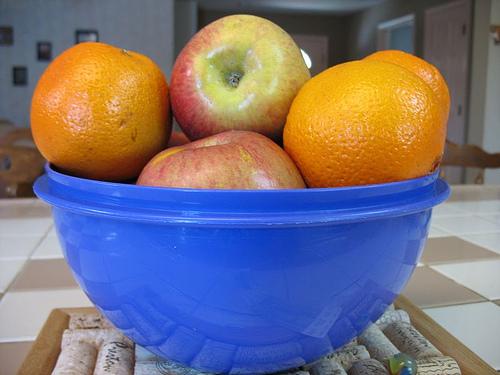Is the fruit in a basket?
Write a very short answer. No. What kind of fruit is shown?
Concise answer only. Apples and oranges. What color is the bowl?
Answer briefly. Blue. 